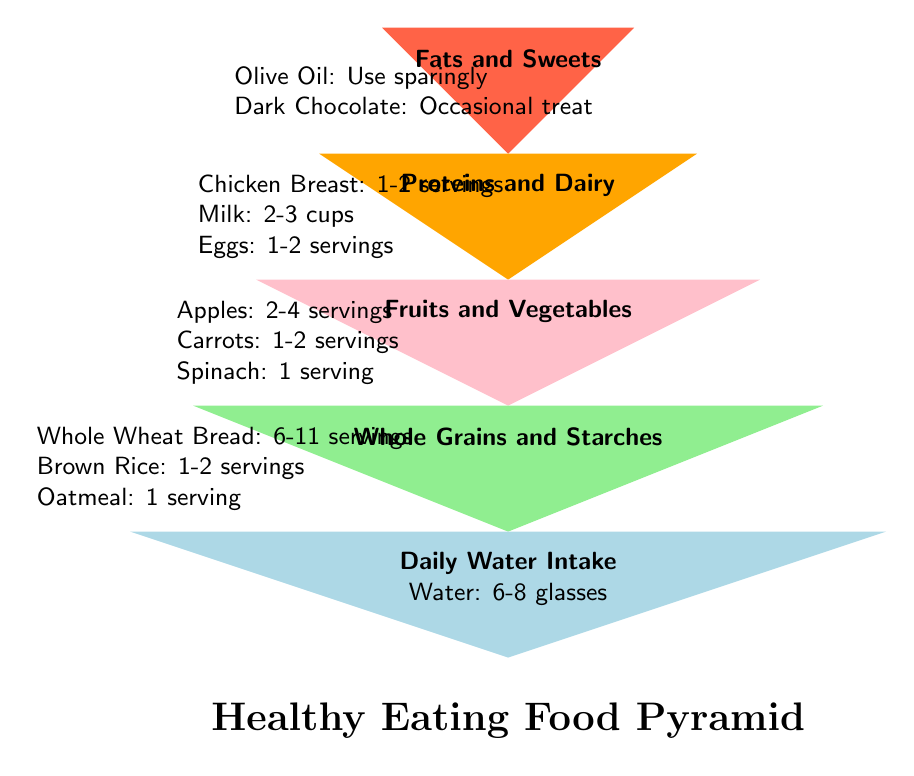What is the highest level of the food pyramid? The highest level is labeled "Fats and Sweets". This can be found at the top of the pyramid which refers to foods that should be consumed sparingly.
Answer: Fats and Sweets How many servings of apples are recommended? The section for Fruits and Vegetables indicates 2-4 servings of apples. This information is located in the middle part of the pyramid.
Answer: 2-4 servings What is the daily recommended water intake? In the pyramid, the bottom level specifically states "Water: 6-8 glasses", which represents the daily water intake suggestion. This is the largest part of the pyramid.
Answer: 6-8 glasses What food is suggested to be used sparingly? The top level lists "Olive Oil" as a food item to be used sparingly, which is part of the Fats and Sweets category.
Answer: Olive Oil Which group has the most servings recommended? Whole Grains and Starches have the most servings recommended, with "6-11 servings" noted in the diagram, found in the section above the daily water intake.
Answer: 6-11 servings What do proteins and dairy include? The Proteins and Dairy level includes foods like chicken breast, milk, and eggs. The serving size is specified next to each food item, in the second level of the pyramid.
Answer: Chicken Breast, Milk, Eggs How many levels are there in the pyramid? The diagram depicts five distinct levels, each representing a different food group or dietary component for healthy eating.
Answer: 5 Which category is at the second highest level? The second level down from the top is for Proteins and Dairy, which indicates the importance of these foods in a balanced diet.
Answer: Proteins and Dairy 